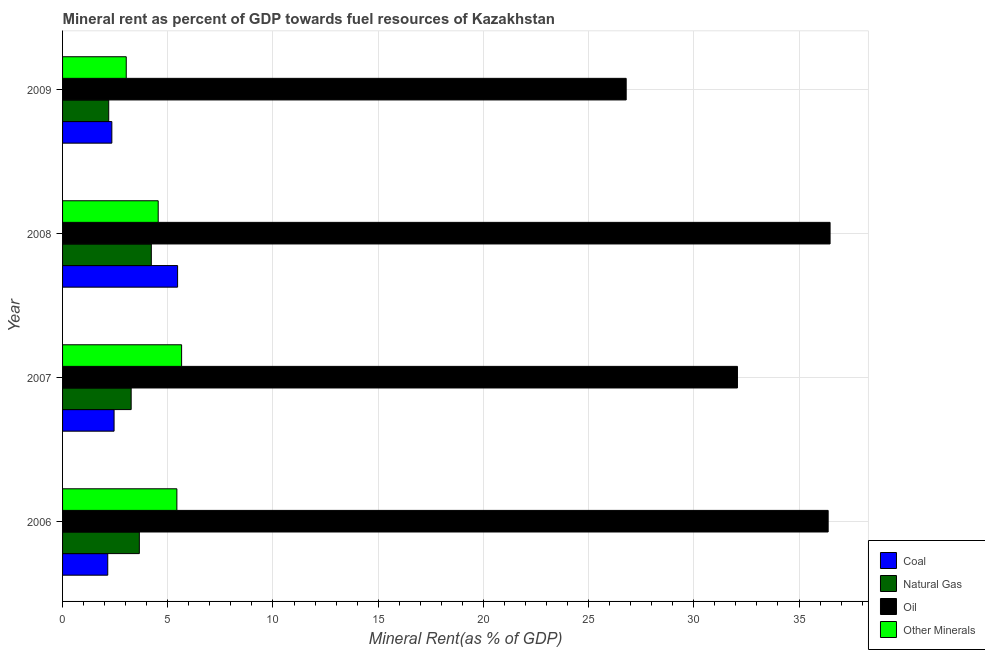How many different coloured bars are there?
Provide a short and direct response. 4. Are the number of bars per tick equal to the number of legend labels?
Give a very brief answer. Yes. Are the number of bars on each tick of the Y-axis equal?
Ensure brevity in your answer.  Yes. How many bars are there on the 2nd tick from the top?
Provide a short and direct response. 4. How many bars are there on the 1st tick from the bottom?
Provide a succinct answer. 4. What is the natural gas rent in 2008?
Provide a short and direct response. 4.22. Across all years, what is the maximum coal rent?
Ensure brevity in your answer.  5.47. Across all years, what is the minimum  rent of other minerals?
Your answer should be compact. 3.03. In which year was the natural gas rent maximum?
Provide a short and direct response. 2008. In which year was the natural gas rent minimum?
Keep it short and to the point. 2009. What is the total natural gas rent in the graph?
Provide a short and direct response. 13.32. What is the difference between the oil rent in 2007 and that in 2008?
Your response must be concise. -4.4. What is the difference between the oil rent in 2007 and the  rent of other minerals in 2006?
Offer a very short reply. 26.64. What is the average  rent of other minerals per year?
Your response must be concise. 4.67. In the year 2008, what is the difference between the natural gas rent and oil rent?
Your response must be concise. -32.26. What is the ratio of the natural gas rent in 2007 to that in 2009?
Provide a succinct answer. 1.49. Is the difference between the  rent of other minerals in 2008 and 2009 greater than the difference between the coal rent in 2008 and 2009?
Your response must be concise. No. What is the difference between the highest and the second highest coal rent?
Your response must be concise. 3.02. What is the difference between the highest and the lowest natural gas rent?
Your response must be concise. 2.03. Is the sum of the coal rent in 2006 and 2009 greater than the maximum oil rent across all years?
Give a very brief answer. No. What does the 3rd bar from the top in 2009 represents?
Your response must be concise. Natural Gas. What does the 3rd bar from the bottom in 2006 represents?
Keep it short and to the point. Oil. How many bars are there?
Provide a short and direct response. 16. Are all the bars in the graph horizontal?
Provide a succinct answer. Yes. How many years are there in the graph?
Provide a short and direct response. 4. Are the values on the major ticks of X-axis written in scientific E-notation?
Offer a terse response. No. Where does the legend appear in the graph?
Offer a very short reply. Bottom right. How are the legend labels stacked?
Provide a short and direct response. Vertical. What is the title of the graph?
Offer a terse response. Mineral rent as percent of GDP towards fuel resources of Kazakhstan. Does "Grants and Revenue" appear as one of the legend labels in the graph?
Provide a succinct answer. No. What is the label or title of the X-axis?
Your answer should be very brief. Mineral Rent(as % of GDP). What is the Mineral Rent(as % of GDP) of Coal in 2006?
Give a very brief answer. 2.15. What is the Mineral Rent(as % of GDP) in Natural Gas in 2006?
Offer a terse response. 3.65. What is the Mineral Rent(as % of GDP) of Oil in 2006?
Your response must be concise. 36.38. What is the Mineral Rent(as % of GDP) in Other Minerals in 2006?
Provide a succinct answer. 5.43. What is the Mineral Rent(as % of GDP) in Coal in 2007?
Keep it short and to the point. 2.45. What is the Mineral Rent(as % of GDP) of Natural Gas in 2007?
Provide a succinct answer. 3.26. What is the Mineral Rent(as % of GDP) of Oil in 2007?
Ensure brevity in your answer.  32.07. What is the Mineral Rent(as % of GDP) of Other Minerals in 2007?
Make the answer very short. 5.66. What is the Mineral Rent(as % of GDP) in Coal in 2008?
Your response must be concise. 5.47. What is the Mineral Rent(as % of GDP) of Natural Gas in 2008?
Your answer should be compact. 4.22. What is the Mineral Rent(as % of GDP) of Oil in 2008?
Your answer should be compact. 36.48. What is the Mineral Rent(as % of GDP) of Other Minerals in 2008?
Offer a very short reply. 4.55. What is the Mineral Rent(as % of GDP) of Coal in 2009?
Provide a short and direct response. 2.34. What is the Mineral Rent(as % of GDP) of Natural Gas in 2009?
Keep it short and to the point. 2.19. What is the Mineral Rent(as % of GDP) of Oil in 2009?
Your answer should be very brief. 26.79. What is the Mineral Rent(as % of GDP) in Other Minerals in 2009?
Offer a very short reply. 3.03. Across all years, what is the maximum Mineral Rent(as % of GDP) of Coal?
Your answer should be compact. 5.47. Across all years, what is the maximum Mineral Rent(as % of GDP) of Natural Gas?
Offer a terse response. 4.22. Across all years, what is the maximum Mineral Rent(as % of GDP) in Oil?
Provide a succinct answer. 36.48. Across all years, what is the maximum Mineral Rent(as % of GDP) in Other Minerals?
Make the answer very short. 5.66. Across all years, what is the minimum Mineral Rent(as % of GDP) of Coal?
Offer a very short reply. 2.15. Across all years, what is the minimum Mineral Rent(as % of GDP) in Natural Gas?
Your answer should be compact. 2.19. Across all years, what is the minimum Mineral Rent(as % of GDP) of Oil?
Your response must be concise. 26.79. Across all years, what is the minimum Mineral Rent(as % of GDP) in Other Minerals?
Ensure brevity in your answer.  3.03. What is the total Mineral Rent(as % of GDP) of Coal in the graph?
Offer a terse response. 12.4. What is the total Mineral Rent(as % of GDP) in Natural Gas in the graph?
Provide a succinct answer. 13.32. What is the total Mineral Rent(as % of GDP) of Oil in the graph?
Provide a short and direct response. 131.72. What is the total Mineral Rent(as % of GDP) in Other Minerals in the graph?
Provide a short and direct response. 18.66. What is the difference between the Mineral Rent(as % of GDP) of Coal in 2006 and that in 2007?
Ensure brevity in your answer.  -0.3. What is the difference between the Mineral Rent(as % of GDP) of Natural Gas in 2006 and that in 2007?
Your answer should be very brief. 0.39. What is the difference between the Mineral Rent(as % of GDP) in Oil in 2006 and that in 2007?
Offer a terse response. 4.31. What is the difference between the Mineral Rent(as % of GDP) in Other Minerals in 2006 and that in 2007?
Give a very brief answer. -0.22. What is the difference between the Mineral Rent(as % of GDP) of Coal in 2006 and that in 2008?
Provide a succinct answer. -3.32. What is the difference between the Mineral Rent(as % of GDP) of Natural Gas in 2006 and that in 2008?
Offer a terse response. -0.57. What is the difference between the Mineral Rent(as % of GDP) of Oil in 2006 and that in 2008?
Provide a short and direct response. -0.09. What is the difference between the Mineral Rent(as % of GDP) in Other Minerals in 2006 and that in 2008?
Make the answer very short. 0.89. What is the difference between the Mineral Rent(as % of GDP) of Coal in 2006 and that in 2009?
Keep it short and to the point. -0.19. What is the difference between the Mineral Rent(as % of GDP) of Natural Gas in 2006 and that in 2009?
Provide a short and direct response. 1.46. What is the difference between the Mineral Rent(as % of GDP) in Oil in 2006 and that in 2009?
Your response must be concise. 9.6. What is the difference between the Mineral Rent(as % of GDP) in Other Minerals in 2006 and that in 2009?
Offer a very short reply. 2.41. What is the difference between the Mineral Rent(as % of GDP) in Coal in 2007 and that in 2008?
Make the answer very short. -3.02. What is the difference between the Mineral Rent(as % of GDP) in Natural Gas in 2007 and that in 2008?
Give a very brief answer. -0.96. What is the difference between the Mineral Rent(as % of GDP) in Oil in 2007 and that in 2008?
Ensure brevity in your answer.  -4.4. What is the difference between the Mineral Rent(as % of GDP) in Other Minerals in 2007 and that in 2008?
Give a very brief answer. 1.11. What is the difference between the Mineral Rent(as % of GDP) of Coal in 2007 and that in 2009?
Give a very brief answer. 0.11. What is the difference between the Mineral Rent(as % of GDP) in Natural Gas in 2007 and that in 2009?
Keep it short and to the point. 1.07. What is the difference between the Mineral Rent(as % of GDP) in Oil in 2007 and that in 2009?
Your answer should be compact. 5.29. What is the difference between the Mineral Rent(as % of GDP) in Other Minerals in 2007 and that in 2009?
Give a very brief answer. 2.63. What is the difference between the Mineral Rent(as % of GDP) in Coal in 2008 and that in 2009?
Give a very brief answer. 3.12. What is the difference between the Mineral Rent(as % of GDP) in Natural Gas in 2008 and that in 2009?
Your response must be concise. 2.03. What is the difference between the Mineral Rent(as % of GDP) of Oil in 2008 and that in 2009?
Your response must be concise. 9.69. What is the difference between the Mineral Rent(as % of GDP) in Other Minerals in 2008 and that in 2009?
Offer a terse response. 1.52. What is the difference between the Mineral Rent(as % of GDP) of Coal in 2006 and the Mineral Rent(as % of GDP) of Natural Gas in 2007?
Your response must be concise. -1.11. What is the difference between the Mineral Rent(as % of GDP) in Coal in 2006 and the Mineral Rent(as % of GDP) in Oil in 2007?
Offer a terse response. -29.93. What is the difference between the Mineral Rent(as % of GDP) in Coal in 2006 and the Mineral Rent(as % of GDP) in Other Minerals in 2007?
Your answer should be compact. -3.51. What is the difference between the Mineral Rent(as % of GDP) of Natural Gas in 2006 and the Mineral Rent(as % of GDP) of Oil in 2007?
Give a very brief answer. -28.42. What is the difference between the Mineral Rent(as % of GDP) of Natural Gas in 2006 and the Mineral Rent(as % of GDP) of Other Minerals in 2007?
Your response must be concise. -2.01. What is the difference between the Mineral Rent(as % of GDP) in Oil in 2006 and the Mineral Rent(as % of GDP) in Other Minerals in 2007?
Ensure brevity in your answer.  30.73. What is the difference between the Mineral Rent(as % of GDP) in Coal in 2006 and the Mineral Rent(as % of GDP) in Natural Gas in 2008?
Ensure brevity in your answer.  -2.07. What is the difference between the Mineral Rent(as % of GDP) of Coal in 2006 and the Mineral Rent(as % of GDP) of Oil in 2008?
Offer a terse response. -34.33. What is the difference between the Mineral Rent(as % of GDP) of Coal in 2006 and the Mineral Rent(as % of GDP) of Other Minerals in 2008?
Provide a short and direct response. -2.4. What is the difference between the Mineral Rent(as % of GDP) in Natural Gas in 2006 and the Mineral Rent(as % of GDP) in Oil in 2008?
Offer a terse response. -32.83. What is the difference between the Mineral Rent(as % of GDP) of Natural Gas in 2006 and the Mineral Rent(as % of GDP) of Other Minerals in 2008?
Offer a very short reply. -0.9. What is the difference between the Mineral Rent(as % of GDP) in Oil in 2006 and the Mineral Rent(as % of GDP) in Other Minerals in 2008?
Make the answer very short. 31.84. What is the difference between the Mineral Rent(as % of GDP) in Coal in 2006 and the Mineral Rent(as % of GDP) in Natural Gas in 2009?
Provide a short and direct response. -0.05. What is the difference between the Mineral Rent(as % of GDP) of Coal in 2006 and the Mineral Rent(as % of GDP) of Oil in 2009?
Give a very brief answer. -24.64. What is the difference between the Mineral Rent(as % of GDP) of Coal in 2006 and the Mineral Rent(as % of GDP) of Other Minerals in 2009?
Keep it short and to the point. -0.88. What is the difference between the Mineral Rent(as % of GDP) of Natural Gas in 2006 and the Mineral Rent(as % of GDP) of Oil in 2009?
Offer a terse response. -23.14. What is the difference between the Mineral Rent(as % of GDP) in Natural Gas in 2006 and the Mineral Rent(as % of GDP) in Other Minerals in 2009?
Make the answer very short. 0.62. What is the difference between the Mineral Rent(as % of GDP) of Oil in 2006 and the Mineral Rent(as % of GDP) of Other Minerals in 2009?
Provide a succinct answer. 33.36. What is the difference between the Mineral Rent(as % of GDP) of Coal in 2007 and the Mineral Rent(as % of GDP) of Natural Gas in 2008?
Provide a short and direct response. -1.77. What is the difference between the Mineral Rent(as % of GDP) in Coal in 2007 and the Mineral Rent(as % of GDP) in Oil in 2008?
Provide a short and direct response. -34.03. What is the difference between the Mineral Rent(as % of GDP) in Coal in 2007 and the Mineral Rent(as % of GDP) in Other Minerals in 2008?
Ensure brevity in your answer.  -2.1. What is the difference between the Mineral Rent(as % of GDP) in Natural Gas in 2007 and the Mineral Rent(as % of GDP) in Oil in 2008?
Your answer should be compact. -33.22. What is the difference between the Mineral Rent(as % of GDP) in Natural Gas in 2007 and the Mineral Rent(as % of GDP) in Other Minerals in 2008?
Make the answer very short. -1.29. What is the difference between the Mineral Rent(as % of GDP) of Oil in 2007 and the Mineral Rent(as % of GDP) of Other Minerals in 2008?
Provide a succinct answer. 27.53. What is the difference between the Mineral Rent(as % of GDP) of Coal in 2007 and the Mineral Rent(as % of GDP) of Natural Gas in 2009?
Your answer should be compact. 0.26. What is the difference between the Mineral Rent(as % of GDP) of Coal in 2007 and the Mineral Rent(as % of GDP) of Oil in 2009?
Your answer should be compact. -24.34. What is the difference between the Mineral Rent(as % of GDP) of Coal in 2007 and the Mineral Rent(as % of GDP) of Other Minerals in 2009?
Your answer should be compact. -0.58. What is the difference between the Mineral Rent(as % of GDP) in Natural Gas in 2007 and the Mineral Rent(as % of GDP) in Oil in 2009?
Ensure brevity in your answer.  -23.53. What is the difference between the Mineral Rent(as % of GDP) in Natural Gas in 2007 and the Mineral Rent(as % of GDP) in Other Minerals in 2009?
Provide a succinct answer. 0.23. What is the difference between the Mineral Rent(as % of GDP) in Oil in 2007 and the Mineral Rent(as % of GDP) in Other Minerals in 2009?
Offer a terse response. 29.05. What is the difference between the Mineral Rent(as % of GDP) of Coal in 2008 and the Mineral Rent(as % of GDP) of Natural Gas in 2009?
Provide a short and direct response. 3.27. What is the difference between the Mineral Rent(as % of GDP) of Coal in 2008 and the Mineral Rent(as % of GDP) of Oil in 2009?
Offer a very short reply. -21.32. What is the difference between the Mineral Rent(as % of GDP) of Coal in 2008 and the Mineral Rent(as % of GDP) of Other Minerals in 2009?
Ensure brevity in your answer.  2.44. What is the difference between the Mineral Rent(as % of GDP) of Natural Gas in 2008 and the Mineral Rent(as % of GDP) of Oil in 2009?
Give a very brief answer. -22.57. What is the difference between the Mineral Rent(as % of GDP) of Natural Gas in 2008 and the Mineral Rent(as % of GDP) of Other Minerals in 2009?
Provide a short and direct response. 1.19. What is the difference between the Mineral Rent(as % of GDP) in Oil in 2008 and the Mineral Rent(as % of GDP) in Other Minerals in 2009?
Your answer should be very brief. 33.45. What is the average Mineral Rent(as % of GDP) in Coal per year?
Keep it short and to the point. 3.1. What is the average Mineral Rent(as % of GDP) of Natural Gas per year?
Your response must be concise. 3.33. What is the average Mineral Rent(as % of GDP) in Oil per year?
Offer a terse response. 32.93. What is the average Mineral Rent(as % of GDP) in Other Minerals per year?
Make the answer very short. 4.67. In the year 2006, what is the difference between the Mineral Rent(as % of GDP) in Coal and Mineral Rent(as % of GDP) in Natural Gas?
Provide a short and direct response. -1.5. In the year 2006, what is the difference between the Mineral Rent(as % of GDP) in Coal and Mineral Rent(as % of GDP) in Oil?
Provide a succinct answer. -34.24. In the year 2006, what is the difference between the Mineral Rent(as % of GDP) of Coal and Mineral Rent(as % of GDP) of Other Minerals?
Provide a short and direct response. -3.29. In the year 2006, what is the difference between the Mineral Rent(as % of GDP) of Natural Gas and Mineral Rent(as % of GDP) of Oil?
Give a very brief answer. -32.73. In the year 2006, what is the difference between the Mineral Rent(as % of GDP) of Natural Gas and Mineral Rent(as % of GDP) of Other Minerals?
Give a very brief answer. -1.78. In the year 2006, what is the difference between the Mineral Rent(as % of GDP) in Oil and Mineral Rent(as % of GDP) in Other Minerals?
Give a very brief answer. 30.95. In the year 2007, what is the difference between the Mineral Rent(as % of GDP) in Coal and Mineral Rent(as % of GDP) in Natural Gas?
Provide a succinct answer. -0.81. In the year 2007, what is the difference between the Mineral Rent(as % of GDP) of Coal and Mineral Rent(as % of GDP) of Oil?
Provide a succinct answer. -29.63. In the year 2007, what is the difference between the Mineral Rent(as % of GDP) in Coal and Mineral Rent(as % of GDP) in Other Minerals?
Make the answer very short. -3.21. In the year 2007, what is the difference between the Mineral Rent(as % of GDP) in Natural Gas and Mineral Rent(as % of GDP) in Oil?
Offer a very short reply. -28.81. In the year 2007, what is the difference between the Mineral Rent(as % of GDP) of Natural Gas and Mineral Rent(as % of GDP) of Other Minerals?
Your answer should be compact. -2.4. In the year 2007, what is the difference between the Mineral Rent(as % of GDP) in Oil and Mineral Rent(as % of GDP) in Other Minerals?
Offer a very short reply. 26.42. In the year 2008, what is the difference between the Mineral Rent(as % of GDP) of Coal and Mineral Rent(as % of GDP) of Natural Gas?
Keep it short and to the point. 1.25. In the year 2008, what is the difference between the Mineral Rent(as % of GDP) of Coal and Mineral Rent(as % of GDP) of Oil?
Give a very brief answer. -31.01. In the year 2008, what is the difference between the Mineral Rent(as % of GDP) of Coal and Mineral Rent(as % of GDP) of Other Minerals?
Ensure brevity in your answer.  0.92. In the year 2008, what is the difference between the Mineral Rent(as % of GDP) in Natural Gas and Mineral Rent(as % of GDP) in Oil?
Your answer should be compact. -32.26. In the year 2008, what is the difference between the Mineral Rent(as % of GDP) in Natural Gas and Mineral Rent(as % of GDP) in Other Minerals?
Offer a terse response. -0.33. In the year 2008, what is the difference between the Mineral Rent(as % of GDP) in Oil and Mineral Rent(as % of GDP) in Other Minerals?
Provide a short and direct response. 31.93. In the year 2009, what is the difference between the Mineral Rent(as % of GDP) in Coal and Mineral Rent(as % of GDP) in Natural Gas?
Your answer should be compact. 0.15. In the year 2009, what is the difference between the Mineral Rent(as % of GDP) of Coal and Mineral Rent(as % of GDP) of Oil?
Provide a succinct answer. -24.44. In the year 2009, what is the difference between the Mineral Rent(as % of GDP) of Coal and Mineral Rent(as % of GDP) of Other Minerals?
Provide a short and direct response. -0.68. In the year 2009, what is the difference between the Mineral Rent(as % of GDP) in Natural Gas and Mineral Rent(as % of GDP) in Oil?
Your answer should be very brief. -24.59. In the year 2009, what is the difference between the Mineral Rent(as % of GDP) of Natural Gas and Mineral Rent(as % of GDP) of Other Minerals?
Keep it short and to the point. -0.83. In the year 2009, what is the difference between the Mineral Rent(as % of GDP) of Oil and Mineral Rent(as % of GDP) of Other Minerals?
Offer a very short reply. 23.76. What is the ratio of the Mineral Rent(as % of GDP) of Coal in 2006 to that in 2007?
Your answer should be very brief. 0.88. What is the ratio of the Mineral Rent(as % of GDP) in Natural Gas in 2006 to that in 2007?
Give a very brief answer. 1.12. What is the ratio of the Mineral Rent(as % of GDP) of Oil in 2006 to that in 2007?
Provide a succinct answer. 1.13. What is the ratio of the Mineral Rent(as % of GDP) of Other Minerals in 2006 to that in 2007?
Make the answer very short. 0.96. What is the ratio of the Mineral Rent(as % of GDP) of Coal in 2006 to that in 2008?
Give a very brief answer. 0.39. What is the ratio of the Mineral Rent(as % of GDP) in Natural Gas in 2006 to that in 2008?
Offer a very short reply. 0.87. What is the ratio of the Mineral Rent(as % of GDP) in Oil in 2006 to that in 2008?
Ensure brevity in your answer.  1. What is the ratio of the Mineral Rent(as % of GDP) in Other Minerals in 2006 to that in 2008?
Offer a very short reply. 1.2. What is the ratio of the Mineral Rent(as % of GDP) in Coal in 2006 to that in 2009?
Ensure brevity in your answer.  0.92. What is the ratio of the Mineral Rent(as % of GDP) in Natural Gas in 2006 to that in 2009?
Keep it short and to the point. 1.66. What is the ratio of the Mineral Rent(as % of GDP) of Oil in 2006 to that in 2009?
Offer a very short reply. 1.36. What is the ratio of the Mineral Rent(as % of GDP) of Other Minerals in 2006 to that in 2009?
Your response must be concise. 1.79. What is the ratio of the Mineral Rent(as % of GDP) of Coal in 2007 to that in 2008?
Ensure brevity in your answer.  0.45. What is the ratio of the Mineral Rent(as % of GDP) of Natural Gas in 2007 to that in 2008?
Your answer should be very brief. 0.77. What is the ratio of the Mineral Rent(as % of GDP) in Oil in 2007 to that in 2008?
Your answer should be very brief. 0.88. What is the ratio of the Mineral Rent(as % of GDP) in Other Minerals in 2007 to that in 2008?
Provide a short and direct response. 1.24. What is the ratio of the Mineral Rent(as % of GDP) of Coal in 2007 to that in 2009?
Your answer should be very brief. 1.05. What is the ratio of the Mineral Rent(as % of GDP) in Natural Gas in 2007 to that in 2009?
Your response must be concise. 1.49. What is the ratio of the Mineral Rent(as % of GDP) in Oil in 2007 to that in 2009?
Your response must be concise. 1.2. What is the ratio of the Mineral Rent(as % of GDP) of Other Minerals in 2007 to that in 2009?
Make the answer very short. 1.87. What is the ratio of the Mineral Rent(as % of GDP) of Coal in 2008 to that in 2009?
Keep it short and to the point. 2.33. What is the ratio of the Mineral Rent(as % of GDP) of Natural Gas in 2008 to that in 2009?
Your response must be concise. 1.92. What is the ratio of the Mineral Rent(as % of GDP) in Oil in 2008 to that in 2009?
Give a very brief answer. 1.36. What is the ratio of the Mineral Rent(as % of GDP) of Other Minerals in 2008 to that in 2009?
Keep it short and to the point. 1.5. What is the difference between the highest and the second highest Mineral Rent(as % of GDP) in Coal?
Keep it short and to the point. 3.02. What is the difference between the highest and the second highest Mineral Rent(as % of GDP) of Natural Gas?
Provide a short and direct response. 0.57. What is the difference between the highest and the second highest Mineral Rent(as % of GDP) in Oil?
Provide a short and direct response. 0.09. What is the difference between the highest and the second highest Mineral Rent(as % of GDP) of Other Minerals?
Your answer should be very brief. 0.22. What is the difference between the highest and the lowest Mineral Rent(as % of GDP) in Coal?
Make the answer very short. 3.32. What is the difference between the highest and the lowest Mineral Rent(as % of GDP) of Natural Gas?
Provide a succinct answer. 2.03. What is the difference between the highest and the lowest Mineral Rent(as % of GDP) of Oil?
Ensure brevity in your answer.  9.69. What is the difference between the highest and the lowest Mineral Rent(as % of GDP) of Other Minerals?
Your response must be concise. 2.63. 